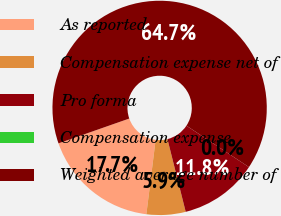Convert chart to OTSL. <chart><loc_0><loc_0><loc_500><loc_500><pie_chart><fcel>As reported<fcel>Compensation expense net of<fcel>Pro forma<fcel>Compensation expense<fcel>Weighted average number of<nl><fcel>17.66%<fcel>5.89%<fcel>11.77%<fcel>0.0%<fcel>64.69%<nl></chart> 